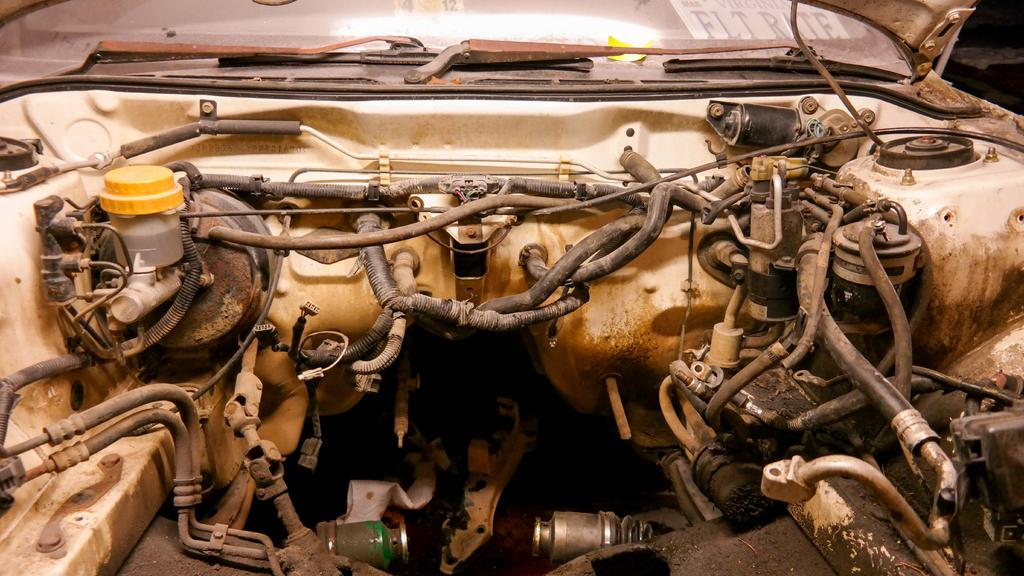What is the main subject of the picture? The main subject of the picture is a car engine space. What can be found inside the car engine space? There are wires, pipes, and filters in the car engine space. Are there any external components visible in the image? Yes, there are two wipers visible in the image. What is the purpose of the wipers? The wipers are used to clean the windshield. How many houses are visible in the image? There are no houses visible in the image; it features a car engine space. What is the interest rate for the car loan in the image? There is no information about a car loan or interest rate in the image. 